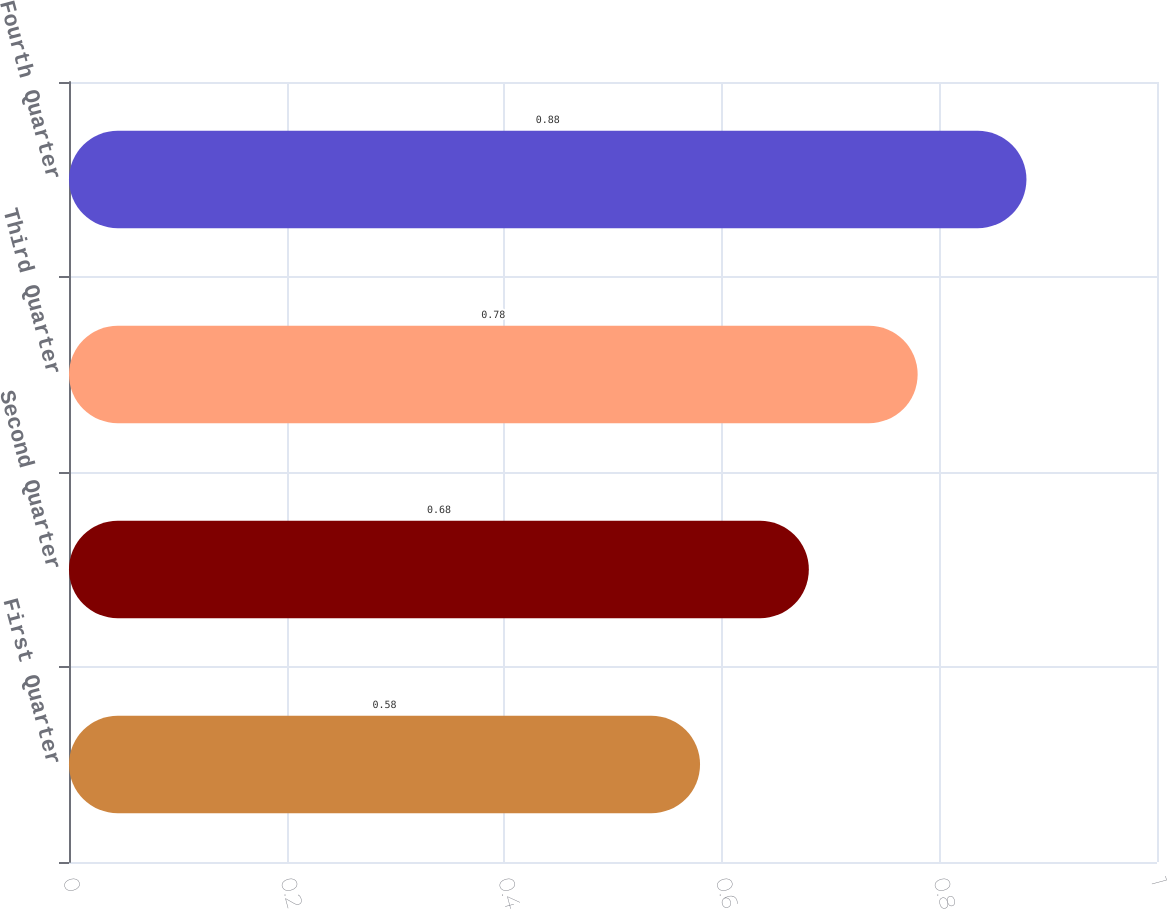Convert chart to OTSL. <chart><loc_0><loc_0><loc_500><loc_500><bar_chart><fcel>First Quarter<fcel>Second Quarter<fcel>Third Quarter<fcel>Fourth Quarter<nl><fcel>0.58<fcel>0.68<fcel>0.78<fcel>0.88<nl></chart> 